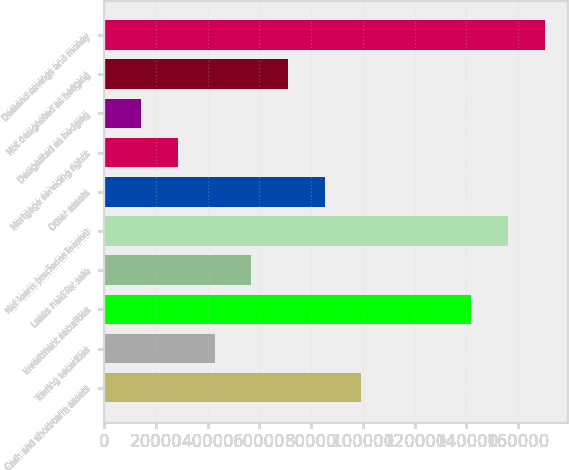<chart> <loc_0><loc_0><loc_500><loc_500><bar_chart><fcel>Cash and short-term assets<fcel>Trading securities<fcel>Investment securities<fcel>Loans held for sale<fcel>Net loans (excludes leases)<fcel>Other assets<fcel>Mortgage servicing rights<fcel>Designated as hedging<fcel>Not designated as hedging<fcel>Demand savings and money<nl><fcel>99444.9<fcel>42718.1<fcel>141990<fcel>56899.8<fcel>156172<fcel>85263.2<fcel>28536.4<fcel>14354.7<fcel>71081.5<fcel>170353<nl></chart> 